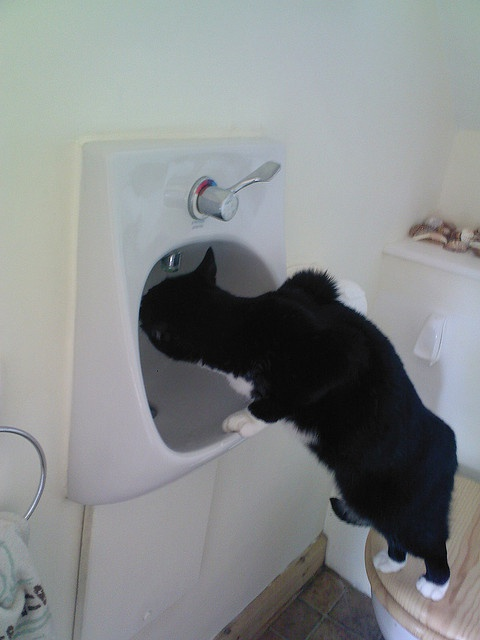Describe the objects in this image and their specific colors. I can see cat in darkgray, black, and gray tones, toilet in darkgray and gray tones, and toilet in darkgray and gray tones in this image. 